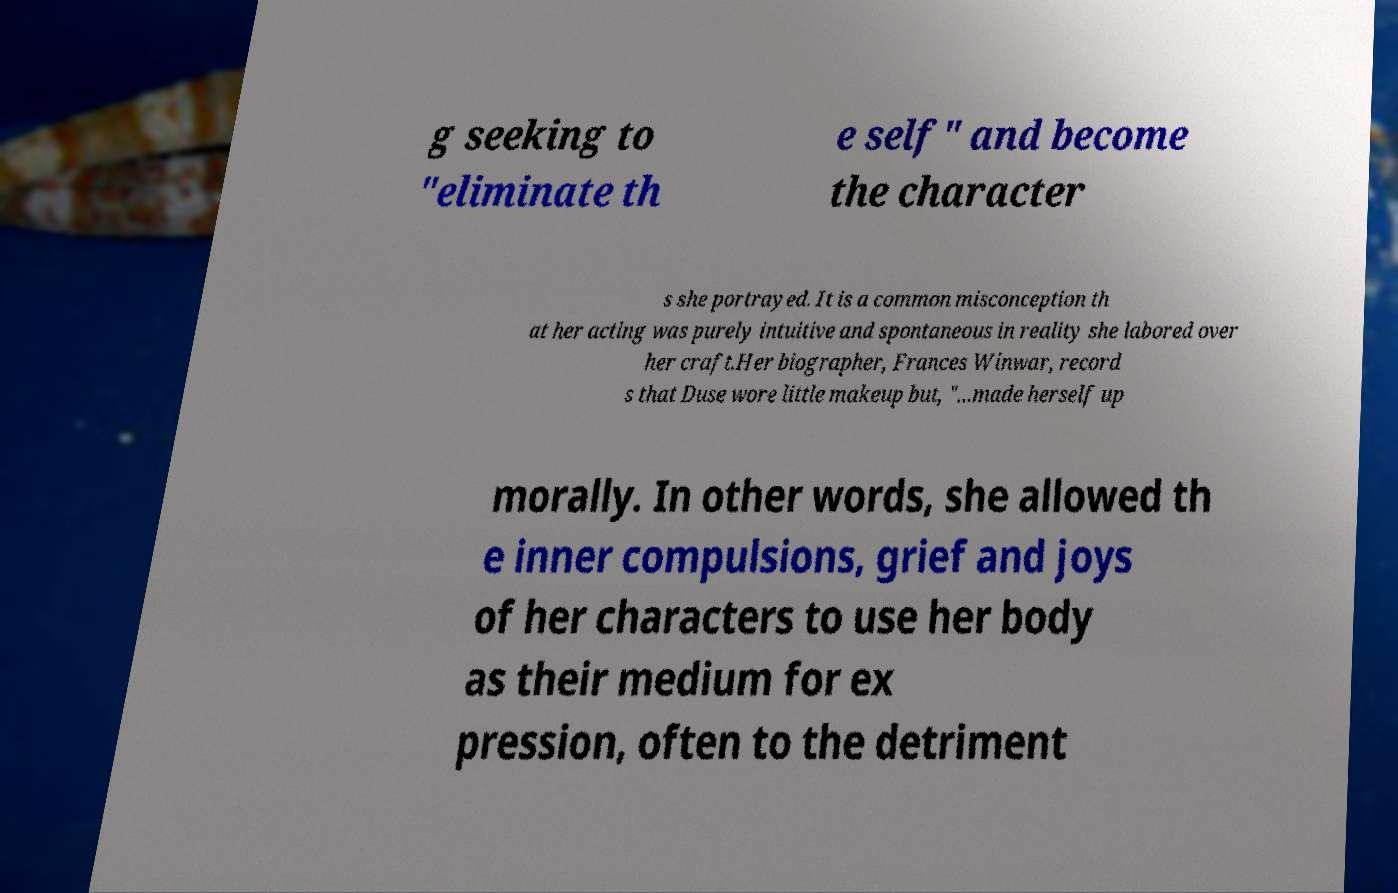For documentation purposes, I need the text within this image transcribed. Could you provide that? g seeking to "eliminate th e self" and become the character s she portrayed. It is a common misconception th at her acting was purely intuitive and spontaneous in reality she labored over her craft.Her biographer, Frances Winwar, record s that Duse wore little makeup but, "...made herself up morally. In other words, she allowed th e inner compulsions, grief and joys of her characters to use her body as their medium for ex pression, often to the detriment 